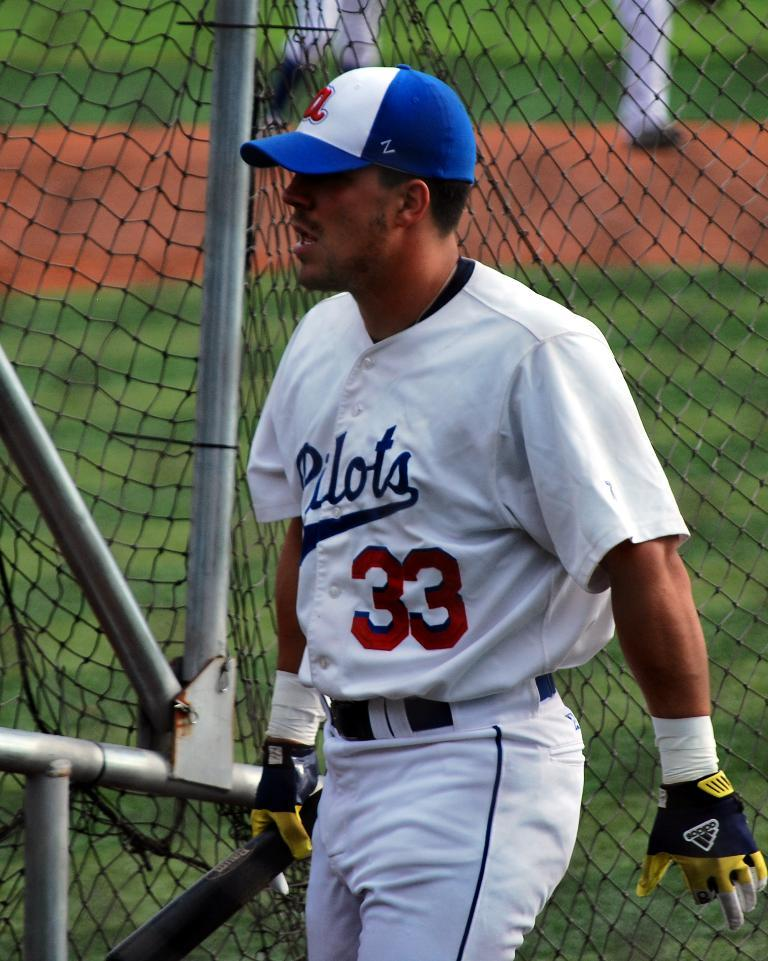<image>
Summarize the visual content of the image. A baseball player in a white uniform for the team the "Pilots" wearing number 33. 